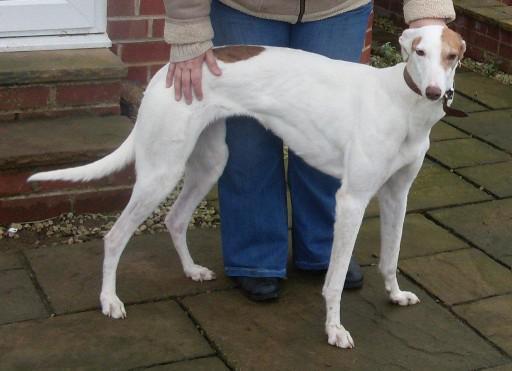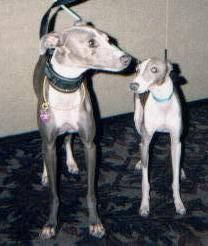The first image is the image on the left, the second image is the image on the right. Analyze the images presented: Is the assertion "The dog in the right image has a red collar around its neck." valid? Answer yes or no. No. The first image is the image on the left, the second image is the image on the right. Given the left and right images, does the statement "There are two dogs in total and one of them is wearing a collar." hold true? Answer yes or no. No. 